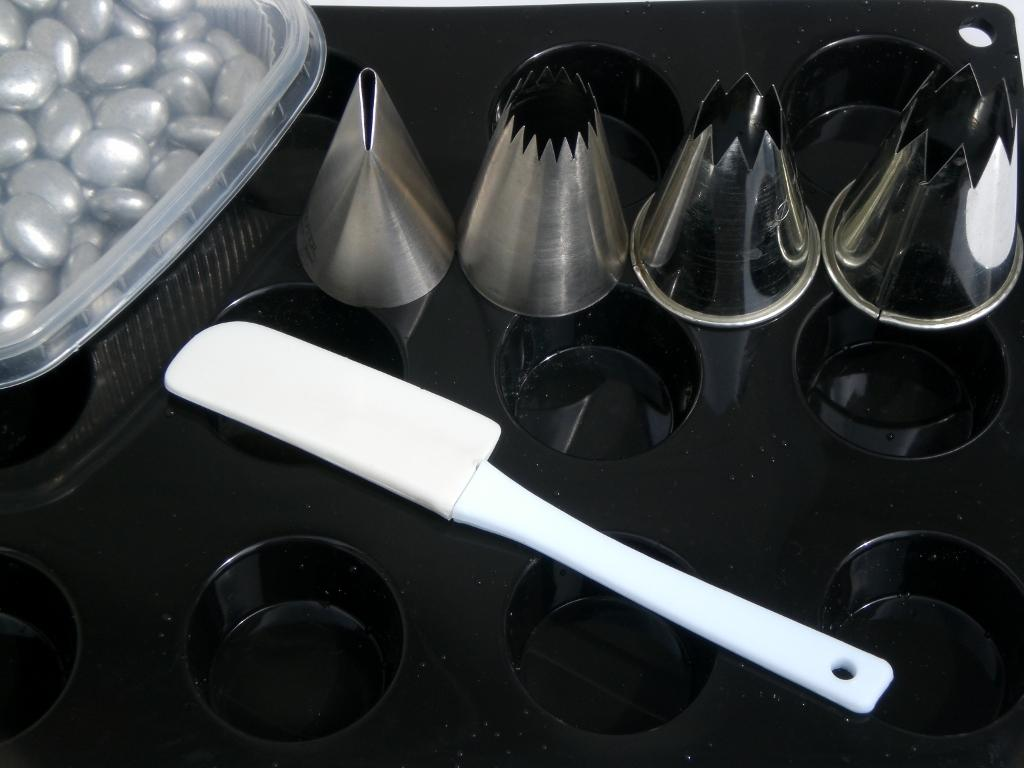What can be seen in the image that resembles molds or shapes? There are molds or shapes in the image. What is the color of the tray in the image? The tray in the image is black. What type of utensil is present in the image? There is a plastic spoon in the image. What type of material are the objects in the image made of? There are steel objects in the image. What position does the leaf hold in the image? There is no leaf present in the image. How is the cord connected to the objects in the image? There is no cord present in the image. 